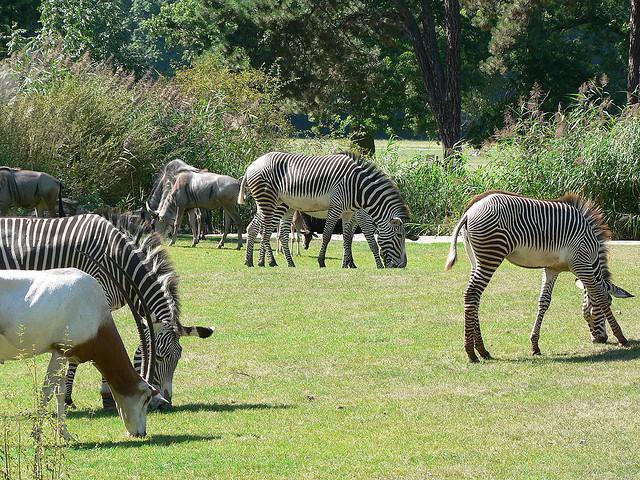How many zebras are in the photo?
Give a very brief answer. 3. How many white cars are on the road?
Give a very brief answer. 0. 